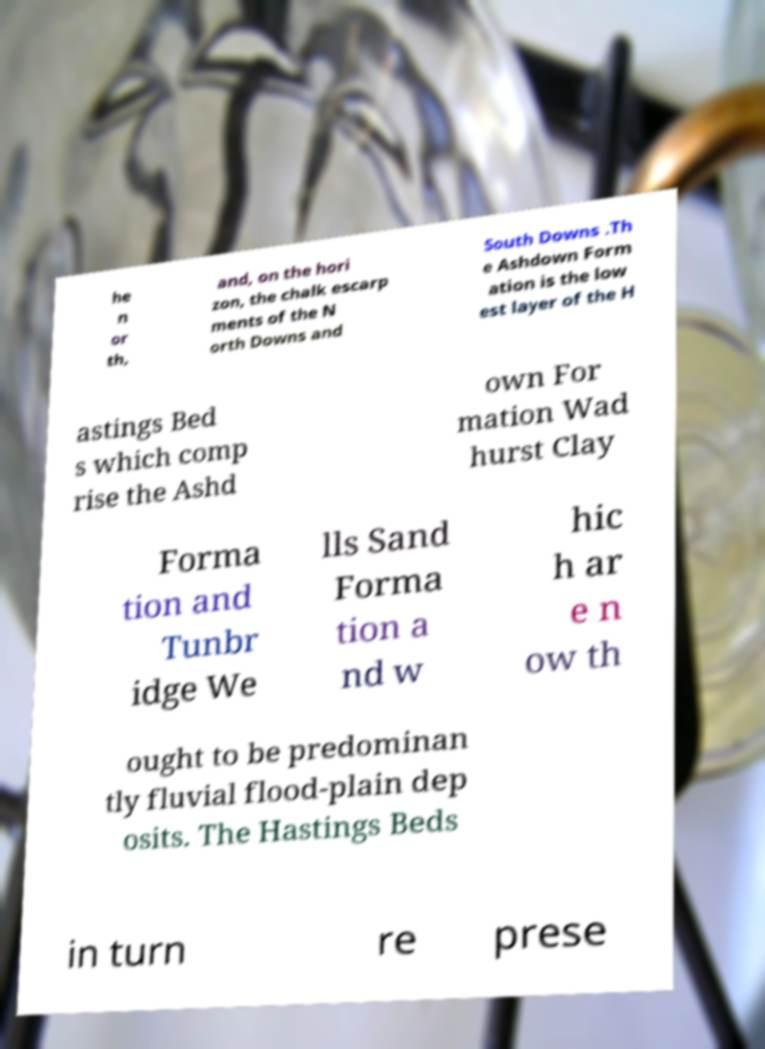Could you assist in decoding the text presented in this image and type it out clearly? he n or th, and, on the hori zon, the chalk escarp ments of the N orth Downs and South Downs .Th e Ashdown Form ation is the low est layer of the H astings Bed s which comp rise the Ashd own For mation Wad hurst Clay Forma tion and Tunbr idge We lls Sand Forma tion a nd w hic h ar e n ow th ought to be predominan tly fluvial flood-plain dep osits. The Hastings Beds in turn re prese 